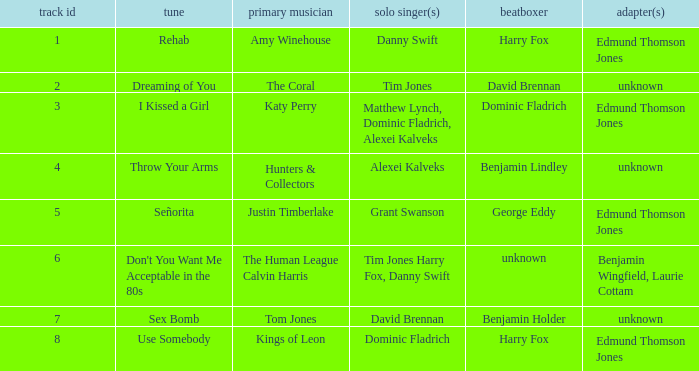Who is the vocal percussionist for Sex Bomb? Benjamin Holder. I'm looking to parse the entire table for insights. Could you assist me with that? {'header': ['track id', 'tune', 'primary musician', 'solo singer(s)', 'beatboxer', 'adapter(s)'], 'rows': [['1', 'Rehab', 'Amy Winehouse', 'Danny Swift', 'Harry Fox', 'Edmund Thomson Jones'], ['2', 'Dreaming of You', 'The Coral', 'Tim Jones', 'David Brennan', 'unknown'], ['3', 'I Kissed a Girl', 'Katy Perry', 'Matthew Lynch, Dominic Fladrich, Alexei Kalveks', 'Dominic Fladrich', 'Edmund Thomson Jones'], ['4', 'Throw Your Arms', 'Hunters & Collectors', 'Alexei Kalveks', 'Benjamin Lindley', 'unknown'], ['5', 'Señorita', 'Justin Timberlake', 'Grant Swanson', 'George Eddy', 'Edmund Thomson Jones'], ['6', "Don't You Want Me Acceptable in the 80s", 'The Human League Calvin Harris', 'Tim Jones Harry Fox, Danny Swift', 'unknown', 'Benjamin Wingfield, Laurie Cottam'], ['7', 'Sex Bomb', 'Tom Jones', 'David Brennan', 'Benjamin Holder', 'unknown'], ['8', 'Use Somebody', 'Kings of Leon', 'Dominic Fladrich', 'Harry Fox', 'Edmund Thomson Jones']]} 